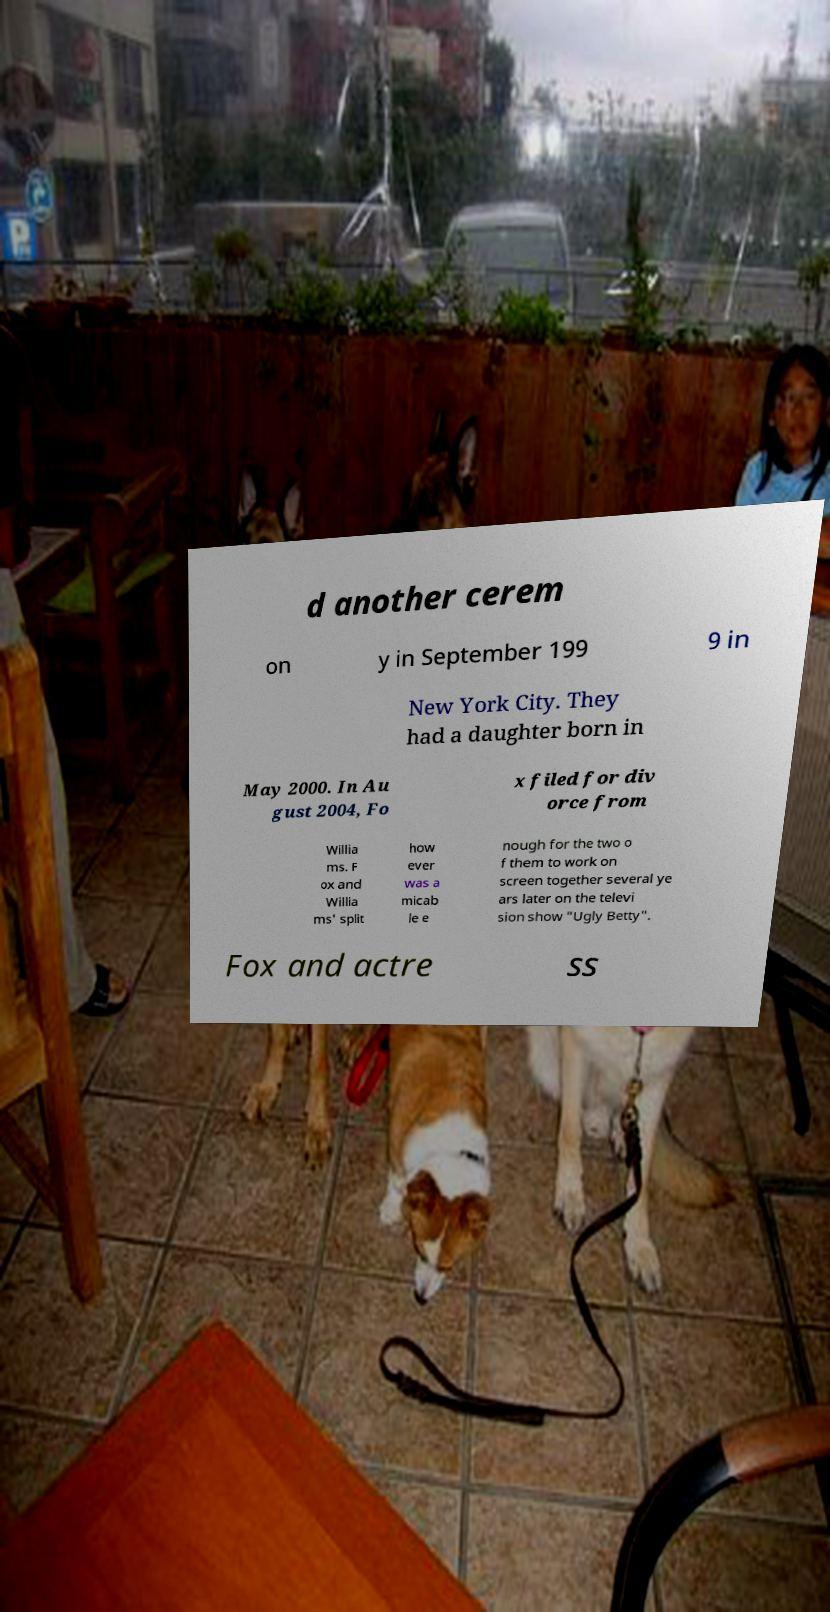I need the written content from this picture converted into text. Can you do that? d another cerem on y in September 199 9 in New York City. They had a daughter born in May 2000. In Au gust 2004, Fo x filed for div orce from Willia ms. F ox and Willia ms' split how ever was a micab le e nough for the two o f them to work on screen together several ye ars later on the televi sion show "Ugly Betty". Fox and actre ss 